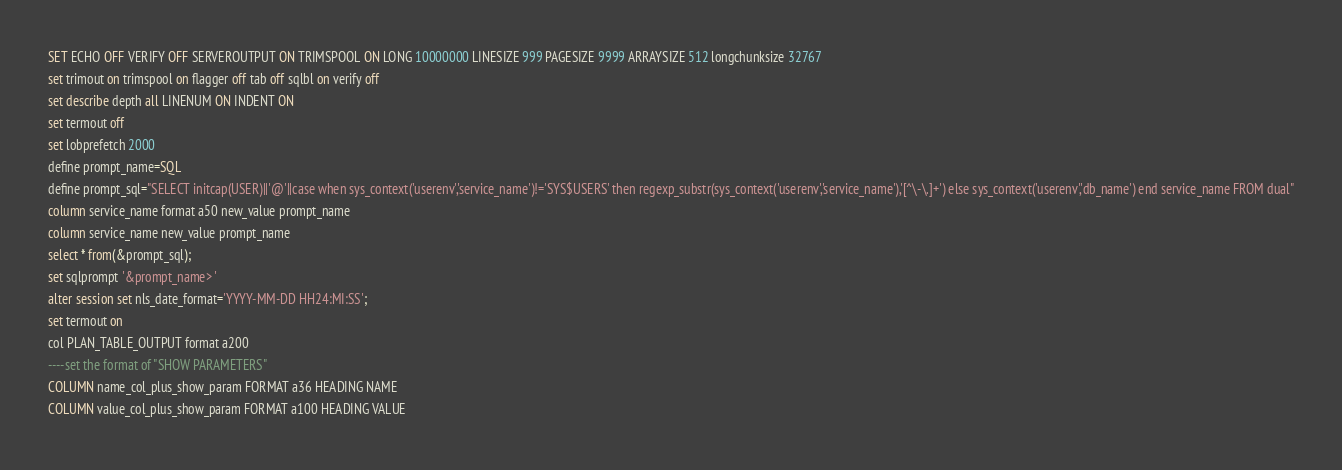<code> <loc_0><loc_0><loc_500><loc_500><_SQL_>SET ECHO OFF VERIFY OFF SERVEROUTPUT ON TRIMSPOOL ON LONG 10000000 LINESIZE 999 PAGESIZE 9999 ARRAYSIZE 512 longchunksize 32767
set trimout on trimspool on flagger off tab off sqlbl on verify off
set describe depth all LINENUM ON INDENT ON
set termout off
set lobprefetch 2000
define prompt_name=SQL
define prompt_sql="SELECT initcap(USER)||'@'||case when sys_context('userenv','service_name')!='SYS$USERS' then regexp_substr(sys_context('userenv','service_name'),'[^\-\.]+') else sys_context('userenv','db_name') end service_name FROM dual"
column service_name format a50 new_value prompt_name
column service_name new_value prompt_name
select * from(&prompt_sql); 
set sqlprompt '&prompt_name> '
alter session set nls_date_format='YYYY-MM-DD HH24:MI:SS';
set termout on
col PLAN_TABLE_OUTPUT format a200
----set the format of "SHOW PARAMETERS"
COLUMN name_col_plus_show_param FORMAT a36 HEADING NAME
COLUMN value_col_plus_show_param FORMAT a100 HEADING VALUE</code> 